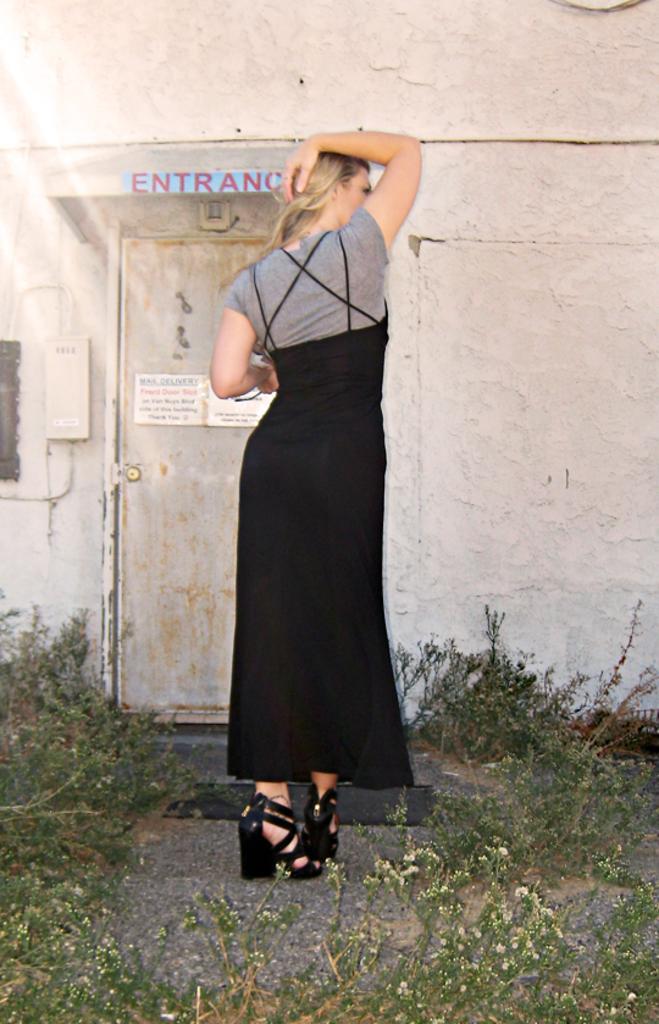Can you describe this image briefly? In this image I see a woman who is wearing grey and black dress and I see that she is standing and I see that she is also wearing black heels and I see plants. In the background I see the wall and I see the door over here and I see a word written over here. 